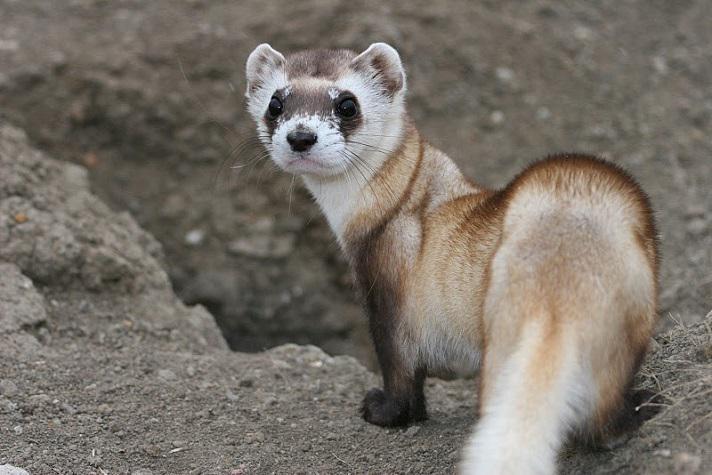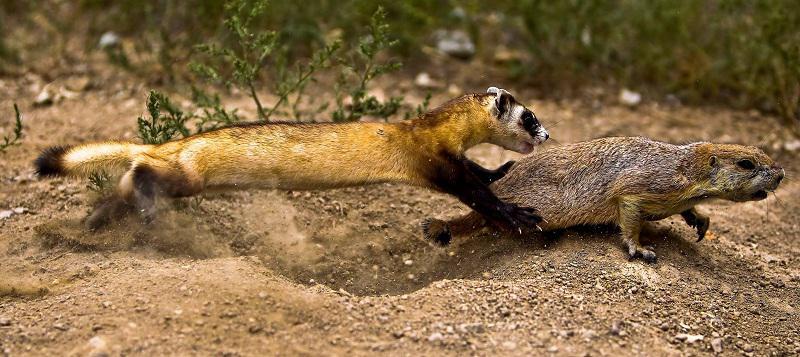The first image is the image on the left, the second image is the image on the right. Considering the images on both sides, is "There are two animals" valid? Answer yes or no. No. The first image is the image on the left, the second image is the image on the right. For the images displayed, is the sentence "Each image contains exactly one animal." factually correct? Answer yes or no. No. 